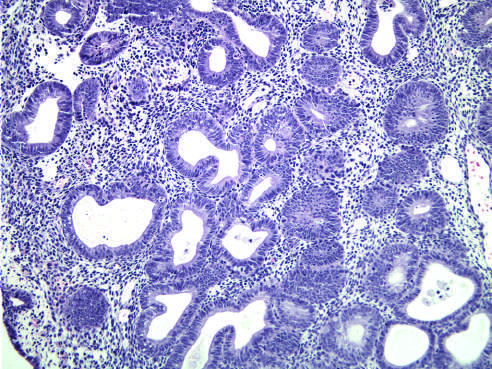what is hyperplasia without atypia characterized by?
Answer the question using a single word or phrase. Nests of closely packed glands 